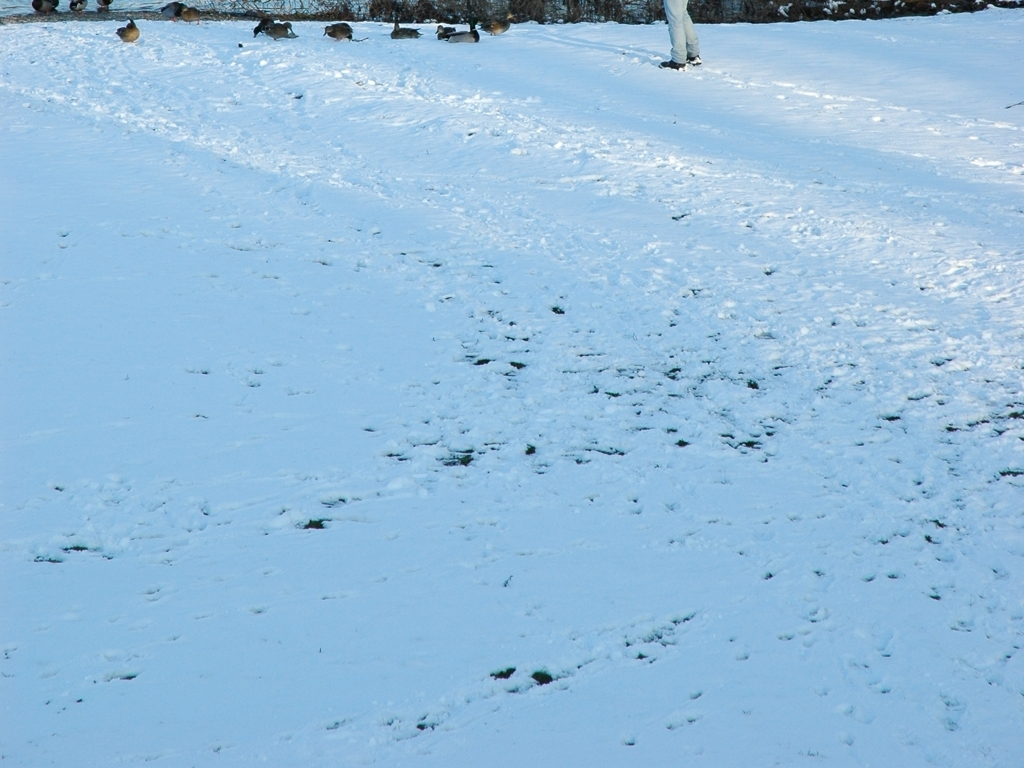Can this image accurately reproduce the color of snow?
 Yes 